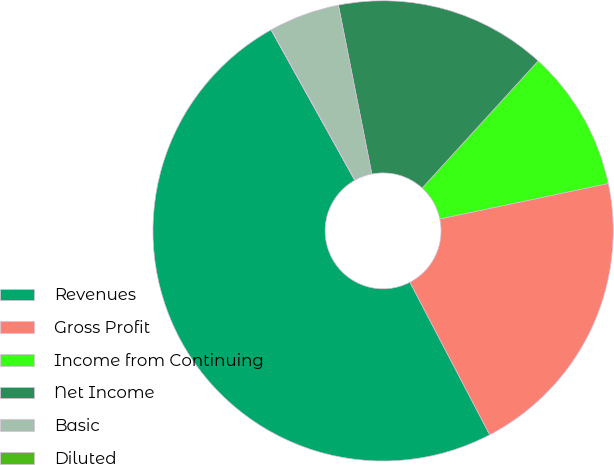Convert chart. <chart><loc_0><loc_0><loc_500><loc_500><pie_chart><fcel>Revenues<fcel>Gross Profit<fcel>Income from Continuing<fcel>Net Income<fcel>Basic<fcel>Diluted<nl><fcel>49.58%<fcel>20.63%<fcel>9.93%<fcel>14.88%<fcel>4.97%<fcel>0.01%<nl></chart> 